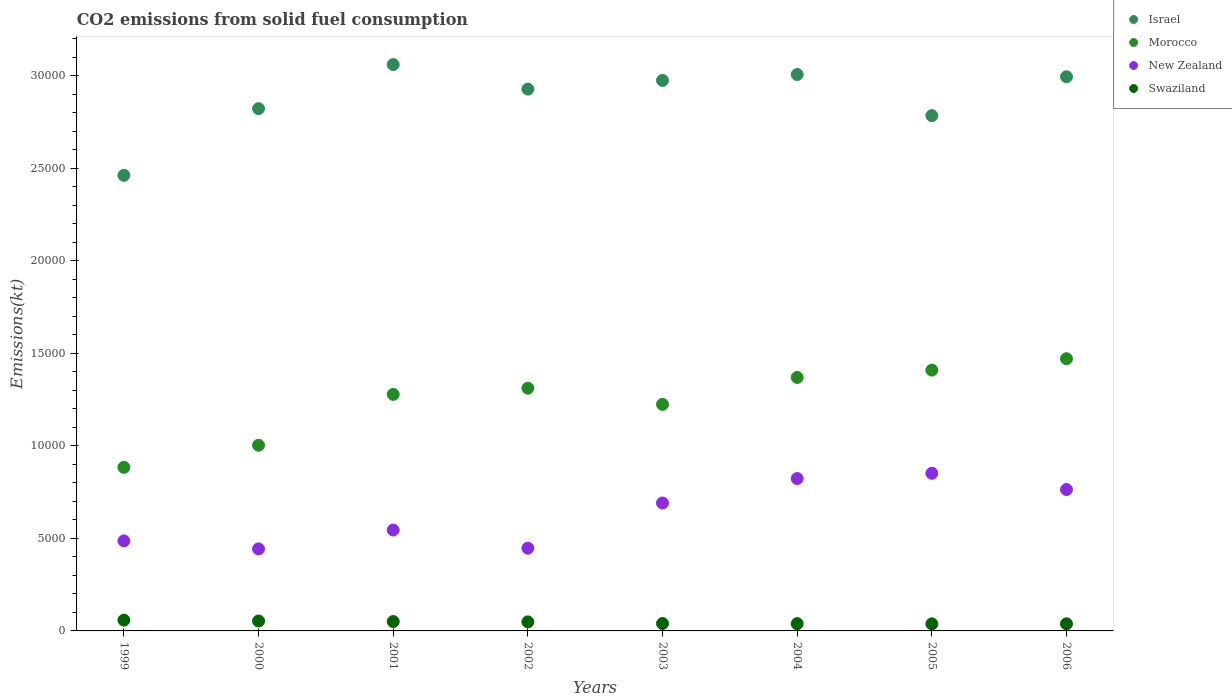How many different coloured dotlines are there?
Provide a short and direct response. 4. What is the amount of CO2 emitted in Israel in 2004?
Your response must be concise. 3.01e+04. Across all years, what is the maximum amount of CO2 emitted in Israel?
Provide a short and direct response. 3.06e+04. Across all years, what is the minimum amount of CO2 emitted in Israel?
Provide a succinct answer. 2.46e+04. In which year was the amount of CO2 emitted in New Zealand maximum?
Offer a very short reply. 2005. In which year was the amount of CO2 emitted in New Zealand minimum?
Your answer should be very brief. 2000. What is the total amount of CO2 emitted in Morocco in the graph?
Keep it short and to the point. 9.95e+04. What is the difference between the amount of CO2 emitted in New Zealand in 2003 and that in 2005?
Offer a terse response. -1606.15. What is the difference between the amount of CO2 emitted in Israel in 2006 and the amount of CO2 emitted in Morocco in 2002?
Provide a short and direct response. 1.68e+04. What is the average amount of CO2 emitted in Israel per year?
Your answer should be compact. 2.88e+04. In the year 2001, what is the difference between the amount of CO2 emitted in New Zealand and amount of CO2 emitted in Israel?
Give a very brief answer. -2.52e+04. What is the ratio of the amount of CO2 emitted in Swaziland in 2002 to that in 2006?
Your answer should be compact. 1.27. What is the difference between the highest and the second highest amount of CO2 emitted in Israel?
Your response must be concise. 539.05. What is the difference between the highest and the lowest amount of CO2 emitted in Israel?
Ensure brevity in your answer.  5988.21. In how many years, is the amount of CO2 emitted in Morocco greater than the average amount of CO2 emitted in Morocco taken over all years?
Your answer should be compact. 5. Is it the case that in every year, the sum of the amount of CO2 emitted in New Zealand and amount of CO2 emitted in Swaziland  is greater than the amount of CO2 emitted in Israel?
Provide a succinct answer. No. Does the amount of CO2 emitted in Israel monotonically increase over the years?
Your response must be concise. No. Is the amount of CO2 emitted in New Zealand strictly greater than the amount of CO2 emitted in Israel over the years?
Make the answer very short. No. Is the amount of CO2 emitted in Swaziland strictly less than the amount of CO2 emitted in New Zealand over the years?
Your response must be concise. Yes. Are the values on the major ticks of Y-axis written in scientific E-notation?
Keep it short and to the point. No. Does the graph contain grids?
Ensure brevity in your answer.  No. How many legend labels are there?
Make the answer very short. 4. How are the legend labels stacked?
Ensure brevity in your answer.  Vertical. What is the title of the graph?
Provide a short and direct response. CO2 emissions from solid fuel consumption. Does "Senegal" appear as one of the legend labels in the graph?
Your answer should be compact. No. What is the label or title of the Y-axis?
Keep it short and to the point. Emissions(kt). What is the Emissions(kt) of Israel in 1999?
Provide a succinct answer. 2.46e+04. What is the Emissions(kt) of Morocco in 1999?
Ensure brevity in your answer.  8841.14. What is the Emissions(kt) of New Zealand in 1999?
Your answer should be compact. 4866.11. What is the Emissions(kt) in Swaziland in 1999?
Your answer should be compact. 583.05. What is the Emissions(kt) of Israel in 2000?
Keep it short and to the point. 2.82e+04. What is the Emissions(kt) of Morocco in 2000?
Your answer should be compact. 1.00e+04. What is the Emissions(kt) of New Zealand in 2000?
Your answer should be compact. 4433.4. What is the Emissions(kt) in Swaziland in 2000?
Your answer should be very brief. 535.38. What is the Emissions(kt) in Israel in 2001?
Provide a succinct answer. 3.06e+04. What is the Emissions(kt) of Morocco in 2001?
Offer a very short reply. 1.28e+04. What is the Emissions(kt) of New Zealand in 2001?
Keep it short and to the point. 5452.83. What is the Emissions(kt) of Swaziland in 2001?
Provide a short and direct response. 506.05. What is the Emissions(kt) of Israel in 2002?
Your answer should be very brief. 2.93e+04. What is the Emissions(kt) of Morocco in 2002?
Make the answer very short. 1.31e+04. What is the Emissions(kt) in New Zealand in 2002?
Provide a short and direct response. 4470.07. What is the Emissions(kt) of Swaziland in 2002?
Your answer should be very brief. 487.71. What is the Emissions(kt) of Israel in 2003?
Offer a terse response. 2.98e+04. What is the Emissions(kt) of Morocco in 2003?
Provide a succinct answer. 1.22e+04. What is the Emissions(kt) of New Zealand in 2003?
Keep it short and to the point. 6912.3. What is the Emissions(kt) in Swaziland in 2003?
Offer a very short reply. 399.7. What is the Emissions(kt) of Israel in 2004?
Your answer should be compact. 3.01e+04. What is the Emissions(kt) in Morocco in 2004?
Offer a very short reply. 1.37e+04. What is the Emissions(kt) of New Zealand in 2004?
Ensure brevity in your answer.  8236.08. What is the Emissions(kt) in Swaziland in 2004?
Give a very brief answer. 392.37. What is the Emissions(kt) in Israel in 2005?
Ensure brevity in your answer.  2.79e+04. What is the Emissions(kt) in Morocco in 2005?
Provide a succinct answer. 1.41e+04. What is the Emissions(kt) in New Zealand in 2005?
Offer a very short reply. 8518.44. What is the Emissions(kt) of Swaziland in 2005?
Ensure brevity in your answer.  381.37. What is the Emissions(kt) of Israel in 2006?
Offer a terse response. 3.00e+04. What is the Emissions(kt) of Morocco in 2006?
Provide a short and direct response. 1.47e+04. What is the Emissions(kt) in New Zealand in 2006?
Offer a very short reply. 7642.03. What is the Emissions(kt) of Swaziland in 2006?
Provide a succinct answer. 385.04. Across all years, what is the maximum Emissions(kt) in Israel?
Offer a terse response. 3.06e+04. Across all years, what is the maximum Emissions(kt) in Morocco?
Give a very brief answer. 1.47e+04. Across all years, what is the maximum Emissions(kt) of New Zealand?
Ensure brevity in your answer.  8518.44. Across all years, what is the maximum Emissions(kt) in Swaziland?
Your answer should be compact. 583.05. Across all years, what is the minimum Emissions(kt) in Israel?
Make the answer very short. 2.46e+04. Across all years, what is the minimum Emissions(kt) in Morocco?
Provide a short and direct response. 8841.14. Across all years, what is the minimum Emissions(kt) of New Zealand?
Give a very brief answer. 4433.4. Across all years, what is the minimum Emissions(kt) of Swaziland?
Your answer should be very brief. 381.37. What is the total Emissions(kt) in Israel in the graph?
Ensure brevity in your answer.  2.30e+05. What is the total Emissions(kt) of Morocco in the graph?
Your response must be concise. 9.95e+04. What is the total Emissions(kt) of New Zealand in the graph?
Provide a succinct answer. 5.05e+04. What is the total Emissions(kt) of Swaziland in the graph?
Make the answer very short. 3670.67. What is the difference between the Emissions(kt) of Israel in 1999 and that in 2000?
Your answer should be very brief. -3604.66. What is the difference between the Emissions(kt) in Morocco in 1999 and that in 2000?
Provide a succinct answer. -1195.44. What is the difference between the Emissions(kt) of New Zealand in 1999 and that in 2000?
Make the answer very short. 432.71. What is the difference between the Emissions(kt) in Swaziland in 1999 and that in 2000?
Ensure brevity in your answer.  47.67. What is the difference between the Emissions(kt) in Israel in 1999 and that in 2001?
Ensure brevity in your answer.  -5988.21. What is the difference between the Emissions(kt) in Morocco in 1999 and that in 2001?
Provide a succinct answer. -3942.03. What is the difference between the Emissions(kt) in New Zealand in 1999 and that in 2001?
Offer a terse response. -586.72. What is the difference between the Emissions(kt) of Swaziland in 1999 and that in 2001?
Ensure brevity in your answer.  77.01. What is the difference between the Emissions(kt) of Israel in 1999 and that in 2002?
Offer a very short reply. -4660.76. What is the difference between the Emissions(kt) in Morocco in 1999 and that in 2002?
Provide a succinct answer. -4275.72. What is the difference between the Emissions(kt) of New Zealand in 1999 and that in 2002?
Offer a very short reply. 396.04. What is the difference between the Emissions(kt) in Swaziland in 1999 and that in 2002?
Offer a very short reply. 95.34. What is the difference between the Emissions(kt) of Israel in 1999 and that in 2003?
Your answer should be compact. -5130.13. What is the difference between the Emissions(kt) in Morocco in 1999 and that in 2003?
Offer a terse response. -3402.98. What is the difference between the Emissions(kt) of New Zealand in 1999 and that in 2003?
Your response must be concise. -2046.19. What is the difference between the Emissions(kt) in Swaziland in 1999 and that in 2003?
Ensure brevity in your answer.  183.35. What is the difference between the Emissions(kt) in Israel in 1999 and that in 2004?
Your response must be concise. -5449.16. What is the difference between the Emissions(kt) in Morocco in 1999 and that in 2004?
Offer a terse response. -4858.77. What is the difference between the Emissions(kt) of New Zealand in 1999 and that in 2004?
Provide a succinct answer. -3369.97. What is the difference between the Emissions(kt) of Swaziland in 1999 and that in 2004?
Offer a very short reply. 190.68. What is the difference between the Emissions(kt) in Israel in 1999 and that in 2005?
Your response must be concise. -3226.96. What is the difference between the Emissions(kt) of Morocco in 1999 and that in 2005?
Offer a terse response. -5254.81. What is the difference between the Emissions(kt) in New Zealand in 1999 and that in 2005?
Your answer should be very brief. -3652.33. What is the difference between the Emissions(kt) in Swaziland in 1999 and that in 2005?
Make the answer very short. 201.69. What is the difference between the Emissions(kt) in Israel in 1999 and that in 2006?
Make the answer very short. -5328.15. What is the difference between the Emissions(kt) in Morocco in 1999 and that in 2006?
Keep it short and to the point. -5870.87. What is the difference between the Emissions(kt) in New Zealand in 1999 and that in 2006?
Your answer should be compact. -2775.92. What is the difference between the Emissions(kt) of Swaziland in 1999 and that in 2006?
Your answer should be compact. 198.02. What is the difference between the Emissions(kt) of Israel in 2000 and that in 2001?
Provide a short and direct response. -2383.55. What is the difference between the Emissions(kt) in Morocco in 2000 and that in 2001?
Your answer should be compact. -2746.58. What is the difference between the Emissions(kt) of New Zealand in 2000 and that in 2001?
Make the answer very short. -1019.43. What is the difference between the Emissions(kt) of Swaziland in 2000 and that in 2001?
Keep it short and to the point. 29.34. What is the difference between the Emissions(kt) of Israel in 2000 and that in 2002?
Provide a short and direct response. -1056.1. What is the difference between the Emissions(kt) of Morocco in 2000 and that in 2002?
Make the answer very short. -3080.28. What is the difference between the Emissions(kt) in New Zealand in 2000 and that in 2002?
Give a very brief answer. -36.67. What is the difference between the Emissions(kt) in Swaziland in 2000 and that in 2002?
Ensure brevity in your answer.  47.67. What is the difference between the Emissions(kt) of Israel in 2000 and that in 2003?
Ensure brevity in your answer.  -1525.47. What is the difference between the Emissions(kt) of Morocco in 2000 and that in 2003?
Offer a terse response. -2207.53. What is the difference between the Emissions(kt) in New Zealand in 2000 and that in 2003?
Offer a very short reply. -2478.89. What is the difference between the Emissions(kt) in Swaziland in 2000 and that in 2003?
Offer a very short reply. 135.68. What is the difference between the Emissions(kt) in Israel in 2000 and that in 2004?
Provide a succinct answer. -1844.5. What is the difference between the Emissions(kt) in Morocco in 2000 and that in 2004?
Ensure brevity in your answer.  -3663.33. What is the difference between the Emissions(kt) of New Zealand in 2000 and that in 2004?
Offer a very short reply. -3802.68. What is the difference between the Emissions(kt) in Swaziland in 2000 and that in 2004?
Provide a short and direct response. 143.01. What is the difference between the Emissions(kt) in Israel in 2000 and that in 2005?
Your response must be concise. 377.7. What is the difference between the Emissions(kt) of Morocco in 2000 and that in 2005?
Your answer should be very brief. -4059.37. What is the difference between the Emissions(kt) in New Zealand in 2000 and that in 2005?
Offer a very short reply. -4085.04. What is the difference between the Emissions(kt) of Swaziland in 2000 and that in 2005?
Your answer should be very brief. 154.01. What is the difference between the Emissions(kt) of Israel in 2000 and that in 2006?
Provide a short and direct response. -1723.49. What is the difference between the Emissions(kt) in Morocco in 2000 and that in 2006?
Ensure brevity in your answer.  -4675.43. What is the difference between the Emissions(kt) in New Zealand in 2000 and that in 2006?
Give a very brief answer. -3208.62. What is the difference between the Emissions(kt) of Swaziland in 2000 and that in 2006?
Your response must be concise. 150.35. What is the difference between the Emissions(kt) in Israel in 2001 and that in 2002?
Your answer should be compact. 1327.45. What is the difference between the Emissions(kt) in Morocco in 2001 and that in 2002?
Give a very brief answer. -333.7. What is the difference between the Emissions(kt) of New Zealand in 2001 and that in 2002?
Your answer should be compact. 982.76. What is the difference between the Emissions(kt) in Swaziland in 2001 and that in 2002?
Your response must be concise. 18.34. What is the difference between the Emissions(kt) of Israel in 2001 and that in 2003?
Make the answer very short. 858.08. What is the difference between the Emissions(kt) of Morocco in 2001 and that in 2003?
Your response must be concise. 539.05. What is the difference between the Emissions(kt) of New Zealand in 2001 and that in 2003?
Offer a terse response. -1459.47. What is the difference between the Emissions(kt) in Swaziland in 2001 and that in 2003?
Provide a short and direct response. 106.34. What is the difference between the Emissions(kt) of Israel in 2001 and that in 2004?
Make the answer very short. 539.05. What is the difference between the Emissions(kt) in Morocco in 2001 and that in 2004?
Provide a short and direct response. -916.75. What is the difference between the Emissions(kt) of New Zealand in 2001 and that in 2004?
Provide a short and direct response. -2783.25. What is the difference between the Emissions(kt) in Swaziland in 2001 and that in 2004?
Ensure brevity in your answer.  113.68. What is the difference between the Emissions(kt) in Israel in 2001 and that in 2005?
Offer a very short reply. 2761.25. What is the difference between the Emissions(kt) of Morocco in 2001 and that in 2005?
Make the answer very short. -1312.79. What is the difference between the Emissions(kt) of New Zealand in 2001 and that in 2005?
Your response must be concise. -3065.61. What is the difference between the Emissions(kt) in Swaziland in 2001 and that in 2005?
Your answer should be compact. 124.68. What is the difference between the Emissions(kt) of Israel in 2001 and that in 2006?
Offer a very short reply. 660.06. What is the difference between the Emissions(kt) of Morocco in 2001 and that in 2006?
Make the answer very short. -1928.84. What is the difference between the Emissions(kt) in New Zealand in 2001 and that in 2006?
Your answer should be compact. -2189.2. What is the difference between the Emissions(kt) in Swaziland in 2001 and that in 2006?
Your response must be concise. 121.01. What is the difference between the Emissions(kt) in Israel in 2002 and that in 2003?
Your response must be concise. -469.38. What is the difference between the Emissions(kt) of Morocco in 2002 and that in 2003?
Your answer should be compact. 872.75. What is the difference between the Emissions(kt) of New Zealand in 2002 and that in 2003?
Offer a terse response. -2442.22. What is the difference between the Emissions(kt) of Swaziland in 2002 and that in 2003?
Keep it short and to the point. 88.01. What is the difference between the Emissions(kt) of Israel in 2002 and that in 2004?
Your answer should be compact. -788.4. What is the difference between the Emissions(kt) of Morocco in 2002 and that in 2004?
Ensure brevity in your answer.  -583.05. What is the difference between the Emissions(kt) in New Zealand in 2002 and that in 2004?
Keep it short and to the point. -3766.01. What is the difference between the Emissions(kt) in Swaziland in 2002 and that in 2004?
Keep it short and to the point. 95.34. What is the difference between the Emissions(kt) in Israel in 2002 and that in 2005?
Ensure brevity in your answer.  1433.8. What is the difference between the Emissions(kt) of Morocco in 2002 and that in 2005?
Your answer should be very brief. -979.09. What is the difference between the Emissions(kt) of New Zealand in 2002 and that in 2005?
Provide a succinct answer. -4048.37. What is the difference between the Emissions(kt) of Swaziland in 2002 and that in 2005?
Offer a terse response. 106.34. What is the difference between the Emissions(kt) of Israel in 2002 and that in 2006?
Your answer should be compact. -667.39. What is the difference between the Emissions(kt) in Morocco in 2002 and that in 2006?
Your answer should be very brief. -1595.14. What is the difference between the Emissions(kt) in New Zealand in 2002 and that in 2006?
Keep it short and to the point. -3171.95. What is the difference between the Emissions(kt) of Swaziland in 2002 and that in 2006?
Give a very brief answer. 102.68. What is the difference between the Emissions(kt) of Israel in 2003 and that in 2004?
Offer a terse response. -319.03. What is the difference between the Emissions(kt) of Morocco in 2003 and that in 2004?
Provide a short and direct response. -1455.8. What is the difference between the Emissions(kt) of New Zealand in 2003 and that in 2004?
Your response must be concise. -1323.79. What is the difference between the Emissions(kt) in Swaziland in 2003 and that in 2004?
Offer a very short reply. 7.33. What is the difference between the Emissions(kt) of Israel in 2003 and that in 2005?
Your answer should be very brief. 1903.17. What is the difference between the Emissions(kt) of Morocco in 2003 and that in 2005?
Your answer should be very brief. -1851.84. What is the difference between the Emissions(kt) in New Zealand in 2003 and that in 2005?
Provide a succinct answer. -1606.15. What is the difference between the Emissions(kt) in Swaziland in 2003 and that in 2005?
Give a very brief answer. 18.34. What is the difference between the Emissions(kt) in Israel in 2003 and that in 2006?
Your answer should be very brief. -198.02. What is the difference between the Emissions(kt) of Morocco in 2003 and that in 2006?
Your answer should be very brief. -2467.89. What is the difference between the Emissions(kt) of New Zealand in 2003 and that in 2006?
Give a very brief answer. -729.73. What is the difference between the Emissions(kt) of Swaziland in 2003 and that in 2006?
Your response must be concise. 14.67. What is the difference between the Emissions(kt) of Israel in 2004 and that in 2005?
Your answer should be compact. 2222.2. What is the difference between the Emissions(kt) of Morocco in 2004 and that in 2005?
Give a very brief answer. -396.04. What is the difference between the Emissions(kt) of New Zealand in 2004 and that in 2005?
Give a very brief answer. -282.36. What is the difference between the Emissions(kt) of Swaziland in 2004 and that in 2005?
Offer a very short reply. 11. What is the difference between the Emissions(kt) in Israel in 2004 and that in 2006?
Offer a very short reply. 121.01. What is the difference between the Emissions(kt) of Morocco in 2004 and that in 2006?
Offer a very short reply. -1012.09. What is the difference between the Emissions(kt) in New Zealand in 2004 and that in 2006?
Offer a very short reply. 594.05. What is the difference between the Emissions(kt) of Swaziland in 2004 and that in 2006?
Your response must be concise. 7.33. What is the difference between the Emissions(kt) in Israel in 2005 and that in 2006?
Keep it short and to the point. -2101.19. What is the difference between the Emissions(kt) in Morocco in 2005 and that in 2006?
Provide a short and direct response. -616.06. What is the difference between the Emissions(kt) in New Zealand in 2005 and that in 2006?
Your response must be concise. 876.41. What is the difference between the Emissions(kt) of Swaziland in 2005 and that in 2006?
Offer a very short reply. -3.67. What is the difference between the Emissions(kt) of Israel in 1999 and the Emissions(kt) of Morocco in 2000?
Offer a terse response. 1.46e+04. What is the difference between the Emissions(kt) in Israel in 1999 and the Emissions(kt) in New Zealand in 2000?
Offer a very short reply. 2.02e+04. What is the difference between the Emissions(kt) in Israel in 1999 and the Emissions(kt) in Swaziland in 2000?
Your answer should be compact. 2.41e+04. What is the difference between the Emissions(kt) in Morocco in 1999 and the Emissions(kt) in New Zealand in 2000?
Offer a terse response. 4407.73. What is the difference between the Emissions(kt) in Morocco in 1999 and the Emissions(kt) in Swaziland in 2000?
Offer a very short reply. 8305.75. What is the difference between the Emissions(kt) in New Zealand in 1999 and the Emissions(kt) in Swaziland in 2000?
Make the answer very short. 4330.73. What is the difference between the Emissions(kt) of Israel in 1999 and the Emissions(kt) of Morocco in 2001?
Provide a short and direct response. 1.18e+04. What is the difference between the Emissions(kt) of Israel in 1999 and the Emissions(kt) of New Zealand in 2001?
Your answer should be compact. 1.92e+04. What is the difference between the Emissions(kt) of Israel in 1999 and the Emissions(kt) of Swaziland in 2001?
Your answer should be compact. 2.41e+04. What is the difference between the Emissions(kt) in Morocco in 1999 and the Emissions(kt) in New Zealand in 2001?
Give a very brief answer. 3388.31. What is the difference between the Emissions(kt) in Morocco in 1999 and the Emissions(kt) in Swaziland in 2001?
Provide a short and direct response. 8335.09. What is the difference between the Emissions(kt) in New Zealand in 1999 and the Emissions(kt) in Swaziland in 2001?
Your answer should be compact. 4360.06. What is the difference between the Emissions(kt) of Israel in 1999 and the Emissions(kt) of Morocco in 2002?
Your answer should be very brief. 1.15e+04. What is the difference between the Emissions(kt) of Israel in 1999 and the Emissions(kt) of New Zealand in 2002?
Ensure brevity in your answer.  2.02e+04. What is the difference between the Emissions(kt) in Israel in 1999 and the Emissions(kt) in Swaziland in 2002?
Your response must be concise. 2.41e+04. What is the difference between the Emissions(kt) of Morocco in 1999 and the Emissions(kt) of New Zealand in 2002?
Your response must be concise. 4371.06. What is the difference between the Emissions(kt) in Morocco in 1999 and the Emissions(kt) in Swaziland in 2002?
Provide a succinct answer. 8353.43. What is the difference between the Emissions(kt) in New Zealand in 1999 and the Emissions(kt) in Swaziland in 2002?
Give a very brief answer. 4378.4. What is the difference between the Emissions(kt) of Israel in 1999 and the Emissions(kt) of Morocco in 2003?
Provide a succinct answer. 1.24e+04. What is the difference between the Emissions(kt) of Israel in 1999 and the Emissions(kt) of New Zealand in 2003?
Your response must be concise. 1.77e+04. What is the difference between the Emissions(kt) of Israel in 1999 and the Emissions(kt) of Swaziland in 2003?
Your answer should be very brief. 2.42e+04. What is the difference between the Emissions(kt) of Morocco in 1999 and the Emissions(kt) of New Zealand in 2003?
Make the answer very short. 1928.84. What is the difference between the Emissions(kt) in Morocco in 1999 and the Emissions(kt) in Swaziland in 2003?
Your response must be concise. 8441.43. What is the difference between the Emissions(kt) of New Zealand in 1999 and the Emissions(kt) of Swaziland in 2003?
Your answer should be very brief. 4466.41. What is the difference between the Emissions(kt) of Israel in 1999 and the Emissions(kt) of Morocco in 2004?
Keep it short and to the point. 1.09e+04. What is the difference between the Emissions(kt) in Israel in 1999 and the Emissions(kt) in New Zealand in 2004?
Provide a short and direct response. 1.64e+04. What is the difference between the Emissions(kt) in Israel in 1999 and the Emissions(kt) in Swaziland in 2004?
Your response must be concise. 2.42e+04. What is the difference between the Emissions(kt) in Morocco in 1999 and the Emissions(kt) in New Zealand in 2004?
Offer a terse response. 605.05. What is the difference between the Emissions(kt) in Morocco in 1999 and the Emissions(kt) in Swaziland in 2004?
Keep it short and to the point. 8448.77. What is the difference between the Emissions(kt) of New Zealand in 1999 and the Emissions(kt) of Swaziland in 2004?
Your answer should be very brief. 4473.74. What is the difference between the Emissions(kt) in Israel in 1999 and the Emissions(kt) in Morocco in 2005?
Give a very brief answer. 1.05e+04. What is the difference between the Emissions(kt) of Israel in 1999 and the Emissions(kt) of New Zealand in 2005?
Your response must be concise. 1.61e+04. What is the difference between the Emissions(kt) of Israel in 1999 and the Emissions(kt) of Swaziland in 2005?
Offer a terse response. 2.42e+04. What is the difference between the Emissions(kt) in Morocco in 1999 and the Emissions(kt) in New Zealand in 2005?
Keep it short and to the point. 322.7. What is the difference between the Emissions(kt) of Morocco in 1999 and the Emissions(kt) of Swaziland in 2005?
Your answer should be compact. 8459.77. What is the difference between the Emissions(kt) of New Zealand in 1999 and the Emissions(kt) of Swaziland in 2005?
Ensure brevity in your answer.  4484.74. What is the difference between the Emissions(kt) of Israel in 1999 and the Emissions(kt) of Morocco in 2006?
Provide a short and direct response. 9911.9. What is the difference between the Emissions(kt) of Israel in 1999 and the Emissions(kt) of New Zealand in 2006?
Offer a terse response. 1.70e+04. What is the difference between the Emissions(kt) of Israel in 1999 and the Emissions(kt) of Swaziland in 2006?
Make the answer very short. 2.42e+04. What is the difference between the Emissions(kt) of Morocco in 1999 and the Emissions(kt) of New Zealand in 2006?
Offer a terse response. 1199.11. What is the difference between the Emissions(kt) in Morocco in 1999 and the Emissions(kt) in Swaziland in 2006?
Give a very brief answer. 8456.1. What is the difference between the Emissions(kt) of New Zealand in 1999 and the Emissions(kt) of Swaziland in 2006?
Your response must be concise. 4481.07. What is the difference between the Emissions(kt) of Israel in 2000 and the Emissions(kt) of Morocco in 2001?
Your answer should be compact. 1.54e+04. What is the difference between the Emissions(kt) in Israel in 2000 and the Emissions(kt) in New Zealand in 2001?
Offer a terse response. 2.28e+04. What is the difference between the Emissions(kt) of Israel in 2000 and the Emissions(kt) of Swaziland in 2001?
Make the answer very short. 2.77e+04. What is the difference between the Emissions(kt) in Morocco in 2000 and the Emissions(kt) in New Zealand in 2001?
Keep it short and to the point. 4583.75. What is the difference between the Emissions(kt) in Morocco in 2000 and the Emissions(kt) in Swaziland in 2001?
Your answer should be very brief. 9530.53. What is the difference between the Emissions(kt) of New Zealand in 2000 and the Emissions(kt) of Swaziland in 2001?
Give a very brief answer. 3927.36. What is the difference between the Emissions(kt) in Israel in 2000 and the Emissions(kt) in Morocco in 2002?
Offer a terse response. 1.51e+04. What is the difference between the Emissions(kt) of Israel in 2000 and the Emissions(kt) of New Zealand in 2002?
Give a very brief answer. 2.38e+04. What is the difference between the Emissions(kt) in Israel in 2000 and the Emissions(kt) in Swaziland in 2002?
Offer a terse response. 2.77e+04. What is the difference between the Emissions(kt) of Morocco in 2000 and the Emissions(kt) of New Zealand in 2002?
Keep it short and to the point. 5566.51. What is the difference between the Emissions(kt) in Morocco in 2000 and the Emissions(kt) in Swaziland in 2002?
Keep it short and to the point. 9548.87. What is the difference between the Emissions(kt) of New Zealand in 2000 and the Emissions(kt) of Swaziland in 2002?
Your answer should be compact. 3945.69. What is the difference between the Emissions(kt) of Israel in 2000 and the Emissions(kt) of Morocco in 2003?
Offer a very short reply. 1.60e+04. What is the difference between the Emissions(kt) of Israel in 2000 and the Emissions(kt) of New Zealand in 2003?
Provide a short and direct response. 2.13e+04. What is the difference between the Emissions(kt) of Israel in 2000 and the Emissions(kt) of Swaziland in 2003?
Offer a very short reply. 2.78e+04. What is the difference between the Emissions(kt) in Morocco in 2000 and the Emissions(kt) in New Zealand in 2003?
Your answer should be very brief. 3124.28. What is the difference between the Emissions(kt) in Morocco in 2000 and the Emissions(kt) in Swaziland in 2003?
Your answer should be very brief. 9636.88. What is the difference between the Emissions(kt) in New Zealand in 2000 and the Emissions(kt) in Swaziland in 2003?
Keep it short and to the point. 4033.7. What is the difference between the Emissions(kt) of Israel in 2000 and the Emissions(kt) of Morocco in 2004?
Provide a short and direct response. 1.45e+04. What is the difference between the Emissions(kt) of Israel in 2000 and the Emissions(kt) of New Zealand in 2004?
Provide a short and direct response. 2.00e+04. What is the difference between the Emissions(kt) in Israel in 2000 and the Emissions(kt) in Swaziland in 2004?
Offer a very short reply. 2.78e+04. What is the difference between the Emissions(kt) of Morocco in 2000 and the Emissions(kt) of New Zealand in 2004?
Your response must be concise. 1800.5. What is the difference between the Emissions(kt) in Morocco in 2000 and the Emissions(kt) in Swaziland in 2004?
Provide a short and direct response. 9644.21. What is the difference between the Emissions(kt) of New Zealand in 2000 and the Emissions(kt) of Swaziland in 2004?
Keep it short and to the point. 4041.03. What is the difference between the Emissions(kt) in Israel in 2000 and the Emissions(kt) in Morocco in 2005?
Your answer should be compact. 1.41e+04. What is the difference between the Emissions(kt) of Israel in 2000 and the Emissions(kt) of New Zealand in 2005?
Your answer should be very brief. 1.97e+04. What is the difference between the Emissions(kt) in Israel in 2000 and the Emissions(kt) in Swaziland in 2005?
Keep it short and to the point. 2.78e+04. What is the difference between the Emissions(kt) in Morocco in 2000 and the Emissions(kt) in New Zealand in 2005?
Offer a very short reply. 1518.14. What is the difference between the Emissions(kt) of Morocco in 2000 and the Emissions(kt) of Swaziland in 2005?
Offer a very short reply. 9655.21. What is the difference between the Emissions(kt) of New Zealand in 2000 and the Emissions(kt) of Swaziland in 2005?
Ensure brevity in your answer.  4052.03. What is the difference between the Emissions(kt) of Israel in 2000 and the Emissions(kt) of Morocco in 2006?
Your answer should be very brief. 1.35e+04. What is the difference between the Emissions(kt) in Israel in 2000 and the Emissions(kt) in New Zealand in 2006?
Give a very brief answer. 2.06e+04. What is the difference between the Emissions(kt) of Israel in 2000 and the Emissions(kt) of Swaziland in 2006?
Offer a very short reply. 2.78e+04. What is the difference between the Emissions(kt) in Morocco in 2000 and the Emissions(kt) in New Zealand in 2006?
Your response must be concise. 2394.55. What is the difference between the Emissions(kt) of Morocco in 2000 and the Emissions(kt) of Swaziland in 2006?
Your answer should be very brief. 9651.54. What is the difference between the Emissions(kt) of New Zealand in 2000 and the Emissions(kt) of Swaziland in 2006?
Your response must be concise. 4048.37. What is the difference between the Emissions(kt) in Israel in 2001 and the Emissions(kt) in Morocco in 2002?
Give a very brief answer. 1.75e+04. What is the difference between the Emissions(kt) of Israel in 2001 and the Emissions(kt) of New Zealand in 2002?
Provide a succinct answer. 2.61e+04. What is the difference between the Emissions(kt) of Israel in 2001 and the Emissions(kt) of Swaziland in 2002?
Your response must be concise. 3.01e+04. What is the difference between the Emissions(kt) of Morocco in 2001 and the Emissions(kt) of New Zealand in 2002?
Your response must be concise. 8313.09. What is the difference between the Emissions(kt) of Morocco in 2001 and the Emissions(kt) of Swaziland in 2002?
Your answer should be very brief. 1.23e+04. What is the difference between the Emissions(kt) of New Zealand in 2001 and the Emissions(kt) of Swaziland in 2002?
Your response must be concise. 4965.12. What is the difference between the Emissions(kt) of Israel in 2001 and the Emissions(kt) of Morocco in 2003?
Your answer should be very brief. 1.84e+04. What is the difference between the Emissions(kt) in Israel in 2001 and the Emissions(kt) in New Zealand in 2003?
Provide a succinct answer. 2.37e+04. What is the difference between the Emissions(kt) of Israel in 2001 and the Emissions(kt) of Swaziland in 2003?
Make the answer very short. 3.02e+04. What is the difference between the Emissions(kt) of Morocco in 2001 and the Emissions(kt) of New Zealand in 2003?
Your answer should be compact. 5870.87. What is the difference between the Emissions(kt) in Morocco in 2001 and the Emissions(kt) in Swaziland in 2003?
Offer a very short reply. 1.24e+04. What is the difference between the Emissions(kt) in New Zealand in 2001 and the Emissions(kt) in Swaziland in 2003?
Provide a short and direct response. 5053.13. What is the difference between the Emissions(kt) in Israel in 2001 and the Emissions(kt) in Morocco in 2004?
Ensure brevity in your answer.  1.69e+04. What is the difference between the Emissions(kt) in Israel in 2001 and the Emissions(kt) in New Zealand in 2004?
Provide a short and direct response. 2.24e+04. What is the difference between the Emissions(kt) of Israel in 2001 and the Emissions(kt) of Swaziland in 2004?
Provide a short and direct response. 3.02e+04. What is the difference between the Emissions(kt) in Morocco in 2001 and the Emissions(kt) in New Zealand in 2004?
Offer a terse response. 4547.08. What is the difference between the Emissions(kt) in Morocco in 2001 and the Emissions(kt) in Swaziland in 2004?
Give a very brief answer. 1.24e+04. What is the difference between the Emissions(kt) in New Zealand in 2001 and the Emissions(kt) in Swaziland in 2004?
Your answer should be very brief. 5060.46. What is the difference between the Emissions(kt) of Israel in 2001 and the Emissions(kt) of Morocco in 2005?
Your answer should be compact. 1.65e+04. What is the difference between the Emissions(kt) in Israel in 2001 and the Emissions(kt) in New Zealand in 2005?
Your answer should be compact. 2.21e+04. What is the difference between the Emissions(kt) in Israel in 2001 and the Emissions(kt) in Swaziland in 2005?
Your response must be concise. 3.02e+04. What is the difference between the Emissions(kt) of Morocco in 2001 and the Emissions(kt) of New Zealand in 2005?
Ensure brevity in your answer.  4264.72. What is the difference between the Emissions(kt) of Morocco in 2001 and the Emissions(kt) of Swaziland in 2005?
Provide a short and direct response. 1.24e+04. What is the difference between the Emissions(kt) in New Zealand in 2001 and the Emissions(kt) in Swaziland in 2005?
Make the answer very short. 5071.46. What is the difference between the Emissions(kt) of Israel in 2001 and the Emissions(kt) of Morocco in 2006?
Offer a terse response. 1.59e+04. What is the difference between the Emissions(kt) of Israel in 2001 and the Emissions(kt) of New Zealand in 2006?
Your answer should be very brief. 2.30e+04. What is the difference between the Emissions(kt) of Israel in 2001 and the Emissions(kt) of Swaziland in 2006?
Make the answer very short. 3.02e+04. What is the difference between the Emissions(kt) in Morocco in 2001 and the Emissions(kt) in New Zealand in 2006?
Your answer should be compact. 5141.13. What is the difference between the Emissions(kt) in Morocco in 2001 and the Emissions(kt) in Swaziland in 2006?
Make the answer very short. 1.24e+04. What is the difference between the Emissions(kt) of New Zealand in 2001 and the Emissions(kt) of Swaziland in 2006?
Make the answer very short. 5067.79. What is the difference between the Emissions(kt) in Israel in 2002 and the Emissions(kt) in Morocco in 2003?
Give a very brief answer. 1.70e+04. What is the difference between the Emissions(kt) in Israel in 2002 and the Emissions(kt) in New Zealand in 2003?
Provide a short and direct response. 2.24e+04. What is the difference between the Emissions(kt) of Israel in 2002 and the Emissions(kt) of Swaziland in 2003?
Provide a short and direct response. 2.89e+04. What is the difference between the Emissions(kt) of Morocco in 2002 and the Emissions(kt) of New Zealand in 2003?
Ensure brevity in your answer.  6204.56. What is the difference between the Emissions(kt) in Morocco in 2002 and the Emissions(kt) in Swaziland in 2003?
Ensure brevity in your answer.  1.27e+04. What is the difference between the Emissions(kt) in New Zealand in 2002 and the Emissions(kt) in Swaziland in 2003?
Keep it short and to the point. 4070.37. What is the difference between the Emissions(kt) in Israel in 2002 and the Emissions(kt) in Morocco in 2004?
Offer a terse response. 1.56e+04. What is the difference between the Emissions(kt) in Israel in 2002 and the Emissions(kt) in New Zealand in 2004?
Provide a succinct answer. 2.10e+04. What is the difference between the Emissions(kt) in Israel in 2002 and the Emissions(kt) in Swaziland in 2004?
Your response must be concise. 2.89e+04. What is the difference between the Emissions(kt) of Morocco in 2002 and the Emissions(kt) of New Zealand in 2004?
Ensure brevity in your answer.  4880.78. What is the difference between the Emissions(kt) in Morocco in 2002 and the Emissions(kt) in Swaziland in 2004?
Offer a terse response. 1.27e+04. What is the difference between the Emissions(kt) in New Zealand in 2002 and the Emissions(kt) in Swaziland in 2004?
Keep it short and to the point. 4077.7. What is the difference between the Emissions(kt) of Israel in 2002 and the Emissions(kt) of Morocco in 2005?
Make the answer very short. 1.52e+04. What is the difference between the Emissions(kt) of Israel in 2002 and the Emissions(kt) of New Zealand in 2005?
Offer a terse response. 2.08e+04. What is the difference between the Emissions(kt) in Israel in 2002 and the Emissions(kt) in Swaziland in 2005?
Give a very brief answer. 2.89e+04. What is the difference between the Emissions(kt) of Morocco in 2002 and the Emissions(kt) of New Zealand in 2005?
Your answer should be very brief. 4598.42. What is the difference between the Emissions(kt) in Morocco in 2002 and the Emissions(kt) in Swaziland in 2005?
Your answer should be very brief. 1.27e+04. What is the difference between the Emissions(kt) of New Zealand in 2002 and the Emissions(kt) of Swaziland in 2005?
Your response must be concise. 4088.7. What is the difference between the Emissions(kt) in Israel in 2002 and the Emissions(kt) in Morocco in 2006?
Ensure brevity in your answer.  1.46e+04. What is the difference between the Emissions(kt) of Israel in 2002 and the Emissions(kt) of New Zealand in 2006?
Offer a very short reply. 2.16e+04. What is the difference between the Emissions(kt) in Israel in 2002 and the Emissions(kt) in Swaziland in 2006?
Give a very brief answer. 2.89e+04. What is the difference between the Emissions(kt) of Morocco in 2002 and the Emissions(kt) of New Zealand in 2006?
Offer a terse response. 5474.83. What is the difference between the Emissions(kt) in Morocco in 2002 and the Emissions(kt) in Swaziland in 2006?
Offer a very short reply. 1.27e+04. What is the difference between the Emissions(kt) in New Zealand in 2002 and the Emissions(kt) in Swaziland in 2006?
Your answer should be very brief. 4085.04. What is the difference between the Emissions(kt) in Israel in 2003 and the Emissions(kt) in Morocco in 2004?
Offer a very short reply. 1.61e+04. What is the difference between the Emissions(kt) of Israel in 2003 and the Emissions(kt) of New Zealand in 2004?
Provide a succinct answer. 2.15e+04. What is the difference between the Emissions(kt) in Israel in 2003 and the Emissions(kt) in Swaziland in 2004?
Your answer should be very brief. 2.94e+04. What is the difference between the Emissions(kt) in Morocco in 2003 and the Emissions(kt) in New Zealand in 2004?
Provide a succinct answer. 4008.03. What is the difference between the Emissions(kt) in Morocco in 2003 and the Emissions(kt) in Swaziland in 2004?
Give a very brief answer. 1.19e+04. What is the difference between the Emissions(kt) of New Zealand in 2003 and the Emissions(kt) of Swaziland in 2004?
Offer a terse response. 6519.93. What is the difference between the Emissions(kt) of Israel in 2003 and the Emissions(kt) of Morocco in 2005?
Your response must be concise. 1.57e+04. What is the difference between the Emissions(kt) of Israel in 2003 and the Emissions(kt) of New Zealand in 2005?
Make the answer very short. 2.12e+04. What is the difference between the Emissions(kt) of Israel in 2003 and the Emissions(kt) of Swaziland in 2005?
Provide a short and direct response. 2.94e+04. What is the difference between the Emissions(kt) of Morocco in 2003 and the Emissions(kt) of New Zealand in 2005?
Your response must be concise. 3725.67. What is the difference between the Emissions(kt) of Morocco in 2003 and the Emissions(kt) of Swaziland in 2005?
Ensure brevity in your answer.  1.19e+04. What is the difference between the Emissions(kt) in New Zealand in 2003 and the Emissions(kt) in Swaziland in 2005?
Your answer should be very brief. 6530.93. What is the difference between the Emissions(kt) of Israel in 2003 and the Emissions(kt) of Morocco in 2006?
Ensure brevity in your answer.  1.50e+04. What is the difference between the Emissions(kt) of Israel in 2003 and the Emissions(kt) of New Zealand in 2006?
Your answer should be compact. 2.21e+04. What is the difference between the Emissions(kt) of Israel in 2003 and the Emissions(kt) of Swaziland in 2006?
Your answer should be compact. 2.94e+04. What is the difference between the Emissions(kt) of Morocco in 2003 and the Emissions(kt) of New Zealand in 2006?
Offer a terse response. 4602.09. What is the difference between the Emissions(kt) of Morocco in 2003 and the Emissions(kt) of Swaziland in 2006?
Keep it short and to the point. 1.19e+04. What is the difference between the Emissions(kt) of New Zealand in 2003 and the Emissions(kt) of Swaziland in 2006?
Your response must be concise. 6527.26. What is the difference between the Emissions(kt) in Israel in 2004 and the Emissions(kt) in Morocco in 2005?
Offer a terse response. 1.60e+04. What is the difference between the Emissions(kt) in Israel in 2004 and the Emissions(kt) in New Zealand in 2005?
Offer a very short reply. 2.16e+04. What is the difference between the Emissions(kt) of Israel in 2004 and the Emissions(kt) of Swaziland in 2005?
Your answer should be compact. 2.97e+04. What is the difference between the Emissions(kt) in Morocco in 2004 and the Emissions(kt) in New Zealand in 2005?
Offer a very short reply. 5181.47. What is the difference between the Emissions(kt) in Morocco in 2004 and the Emissions(kt) in Swaziland in 2005?
Your response must be concise. 1.33e+04. What is the difference between the Emissions(kt) of New Zealand in 2004 and the Emissions(kt) of Swaziland in 2005?
Give a very brief answer. 7854.71. What is the difference between the Emissions(kt) in Israel in 2004 and the Emissions(kt) in Morocco in 2006?
Offer a terse response. 1.54e+04. What is the difference between the Emissions(kt) in Israel in 2004 and the Emissions(kt) in New Zealand in 2006?
Offer a very short reply. 2.24e+04. What is the difference between the Emissions(kt) in Israel in 2004 and the Emissions(kt) in Swaziland in 2006?
Your response must be concise. 2.97e+04. What is the difference between the Emissions(kt) in Morocco in 2004 and the Emissions(kt) in New Zealand in 2006?
Offer a very short reply. 6057.88. What is the difference between the Emissions(kt) of Morocco in 2004 and the Emissions(kt) of Swaziland in 2006?
Provide a succinct answer. 1.33e+04. What is the difference between the Emissions(kt) of New Zealand in 2004 and the Emissions(kt) of Swaziland in 2006?
Offer a very short reply. 7851.05. What is the difference between the Emissions(kt) of Israel in 2005 and the Emissions(kt) of Morocco in 2006?
Keep it short and to the point. 1.31e+04. What is the difference between the Emissions(kt) of Israel in 2005 and the Emissions(kt) of New Zealand in 2006?
Offer a terse response. 2.02e+04. What is the difference between the Emissions(kt) in Israel in 2005 and the Emissions(kt) in Swaziland in 2006?
Provide a succinct answer. 2.75e+04. What is the difference between the Emissions(kt) of Morocco in 2005 and the Emissions(kt) of New Zealand in 2006?
Keep it short and to the point. 6453.92. What is the difference between the Emissions(kt) in Morocco in 2005 and the Emissions(kt) in Swaziland in 2006?
Keep it short and to the point. 1.37e+04. What is the difference between the Emissions(kt) in New Zealand in 2005 and the Emissions(kt) in Swaziland in 2006?
Offer a terse response. 8133.41. What is the average Emissions(kt) of Israel per year?
Offer a very short reply. 2.88e+04. What is the average Emissions(kt) of Morocco per year?
Your answer should be compact. 1.24e+04. What is the average Emissions(kt) in New Zealand per year?
Your answer should be compact. 6316.41. What is the average Emissions(kt) in Swaziland per year?
Ensure brevity in your answer.  458.83. In the year 1999, what is the difference between the Emissions(kt) of Israel and Emissions(kt) of Morocco?
Offer a very short reply. 1.58e+04. In the year 1999, what is the difference between the Emissions(kt) of Israel and Emissions(kt) of New Zealand?
Keep it short and to the point. 1.98e+04. In the year 1999, what is the difference between the Emissions(kt) in Israel and Emissions(kt) in Swaziland?
Offer a terse response. 2.40e+04. In the year 1999, what is the difference between the Emissions(kt) in Morocco and Emissions(kt) in New Zealand?
Offer a very short reply. 3975.03. In the year 1999, what is the difference between the Emissions(kt) in Morocco and Emissions(kt) in Swaziland?
Offer a terse response. 8258.08. In the year 1999, what is the difference between the Emissions(kt) in New Zealand and Emissions(kt) in Swaziland?
Make the answer very short. 4283.06. In the year 2000, what is the difference between the Emissions(kt) in Israel and Emissions(kt) in Morocco?
Your answer should be very brief. 1.82e+04. In the year 2000, what is the difference between the Emissions(kt) of Israel and Emissions(kt) of New Zealand?
Provide a succinct answer. 2.38e+04. In the year 2000, what is the difference between the Emissions(kt) of Israel and Emissions(kt) of Swaziland?
Your response must be concise. 2.77e+04. In the year 2000, what is the difference between the Emissions(kt) in Morocco and Emissions(kt) in New Zealand?
Offer a terse response. 5603.18. In the year 2000, what is the difference between the Emissions(kt) of Morocco and Emissions(kt) of Swaziland?
Offer a very short reply. 9501.2. In the year 2000, what is the difference between the Emissions(kt) in New Zealand and Emissions(kt) in Swaziland?
Ensure brevity in your answer.  3898.02. In the year 2001, what is the difference between the Emissions(kt) of Israel and Emissions(kt) of Morocco?
Your response must be concise. 1.78e+04. In the year 2001, what is the difference between the Emissions(kt) in Israel and Emissions(kt) in New Zealand?
Give a very brief answer. 2.52e+04. In the year 2001, what is the difference between the Emissions(kt) in Israel and Emissions(kt) in Swaziland?
Keep it short and to the point. 3.01e+04. In the year 2001, what is the difference between the Emissions(kt) in Morocco and Emissions(kt) in New Zealand?
Give a very brief answer. 7330.33. In the year 2001, what is the difference between the Emissions(kt) of Morocco and Emissions(kt) of Swaziland?
Offer a terse response. 1.23e+04. In the year 2001, what is the difference between the Emissions(kt) in New Zealand and Emissions(kt) in Swaziland?
Your response must be concise. 4946.78. In the year 2002, what is the difference between the Emissions(kt) of Israel and Emissions(kt) of Morocco?
Offer a very short reply. 1.62e+04. In the year 2002, what is the difference between the Emissions(kt) in Israel and Emissions(kt) in New Zealand?
Offer a terse response. 2.48e+04. In the year 2002, what is the difference between the Emissions(kt) of Israel and Emissions(kt) of Swaziland?
Keep it short and to the point. 2.88e+04. In the year 2002, what is the difference between the Emissions(kt) in Morocco and Emissions(kt) in New Zealand?
Offer a very short reply. 8646.79. In the year 2002, what is the difference between the Emissions(kt) in Morocco and Emissions(kt) in Swaziland?
Give a very brief answer. 1.26e+04. In the year 2002, what is the difference between the Emissions(kt) of New Zealand and Emissions(kt) of Swaziland?
Your response must be concise. 3982.36. In the year 2003, what is the difference between the Emissions(kt) in Israel and Emissions(kt) in Morocco?
Your response must be concise. 1.75e+04. In the year 2003, what is the difference between the Emissions(kt) of Israel and Emissions(kt) of New Zealand?
Offer a terse response. 2.28e+04. In the year 2003, what is the difference between the Emissions(kt) of Israel and Emissions(kt) of Swaziland?
Your answer should be very brief. 2.94e+04. In the year 2003, what is the difference between the Emissions(kt) in Morocco and Emissions(kt) in New Zealand?
Give a very brief answer. 5331.82. In the year 2003, what is the difference between the Emissions(kt) in Morocco and Emissions(kt) in Swaziland?
Keep it short and to the point. 1.18e+04. In the year 2003, what is the difference between the Emissions(kt) in New Zealand and Emissions(kt) in Swaziland?
Offer a very short reply. 6512.59. In the year 2004, what is the difference between the Emissions(kt) in Israel and Emissions(kt) in Morocco?
Give a very brief answer. 1.64e+04. In the year 2004, what is the difference between the Emissions(kt) of Israel and Emissions(kt) of New Zealand?
Offer a terse response. 2.18e+04. In the year 2004, what is the difference between the Emissions(kt) of Israel and Emissions(kt) of Swaziland?
Give a very brief answer. 2.97e+04. In the year 2004, what is the difference between the Emissions(kt) of Morocco and Emissions(kt) of New Zealand?
Offer a terse response. 5463.83. In the year 2004, what is the difference between the Emissions(kt) of Morocco and Emissions(kt) of Swaziland?
Ensure brevity in your answer.  1.33e+04. In the year 2004, what is the difference between the Emissions(kt) of New Zealand and Emissions(kt) of Swaziland?
Your response must be concise. 7843.71. In the year 2005, what is the difference between the Emissions(kt) of Israel and Emissions(kt) of Morocco?
Offer a terse response. 1.38e+04. In the year 2005, what is the difference between the Emissions(kt) of Israel and Emissions(kt) of New Zealand?
Your answer should be very brief. 1.93e+04. In the year 2005, what is the difference between the Emissions(kt) of Israel and Emissions(kt) of Swaziland?
Provide a succinct answer. 2.75e+04. In the year 2005, what is the difference between the Emissions(kt) of Morocco and Emissions(kt) of New Zealand?
Make the answer very short. 5577.51. In the year 2005, what is the difference between the Emissions(kt) in Morocco and Emissions(kt) in Swaziland?
Your answer should be very brief. 1.37e+04. In the year 2005, what is the difference between the Emissions(kt) in New Zealand and Emissions(kt) in Swaziland?
Keep it short and to the point. 8137.07. In the year 2006, what is the difference between the Emissions(kt) in Israel and Emissions(kt) in Morocco?
Give a very brief answer. 1.52e+04. In the year 2006, what is the difference between the Emissions(kt) in Israel and Emissions(kt) in New Zealand?
Provide a succinct answer. 2.23e+04. In the year 2006, what is the difference between the Emissions(kt) in Israel and Emissions(kt) in Swaziland?
Your answer should be very brief. 2.96e+04. In the year 2006, what is the difference between the Emissions(kt) in Morocco and Emissions(kt) in New Zealand?
Provide a short and direct response. 7069.98. In the year 2006, what is the difference between the Emissions(kt) of Morocco and Emissions(kt) of Swaziland?
Your answer should be compact. 1.43e+04. In the year 2006, what is the difference between the Emissions(kt) of New Zealand and Emissions(kt) of Swaziland?
Your answer should be very brief. 7256.99. What is the ratio of the Emissions(kt) in Israel in 1999 to that in 2000?
Your answer should be very brief. 0.87. What is the ratio of the Emissions(kt) in Morocco in 1999 to that in 2000?
Offer a terse response. 0.88. What is the ratio of the Emissions(kt) of New Zealand in 1999 to that in 2000?
Offer a very short reply. 1.1. What is the ratio of the Emissions(kt) in Swaziland in 1999 to that in 2000?
Provide a short and direct response. 1.09. What is the ratio of the Emissions(kt) of Israel in 1999 to that in 2001?
Provide a succinct answer. 0.8. What is the ratio of the Emissions(kt) in Morocco in 1999 to that in 2001?
Keep it short and to the point. 0.69. What is the ratio of the Emissions(kt) of New Zealand in 1999 to that in 2001?
Keep it short and to the point. 0.89. What is the ratio of the Emissions(kt) of Swaziland in 1999 to that in 2001?
Provide a short and direct response. 1.15. What is the ratio of the Emissions(kt) of Israel in 1999 to that in 2002?
Offer a terse response. 0.84. What is the ratio of the Emissions(kt) of Morocco in 1999 to that in 2002?
Give a very brief answer. 0.67. What is the ratio of the Emissions(kt) in New Zealand in 1999 to that in 2002?
Ensure brevity in your answer.  1.09. What is the ratio of the Emissions(kt) in Swaziland in 1999 to that in 2002?
Offer a terse response. 1.2. What is the ratio of the Emissions(kt) in Israel in 1999 to that in 2003?
Provide a short and direct response. 0.83. What is the ratio of the Emissions(kt) of Morocco in 1999 to that in 2003?
Give a very brief answer. 0.72. What is the ratio of the Emissions(kt) in New Zealand in 1999 to that in 2003?
Give a very brief answer. 0.7. What is the ratio of the Emissions(kt) in Swaziland in 1999 to that in 2003?
Give a very brief answer. 1.46. What is the ratio of the Emissions(kt) of Israel in 1999 to that in 2004?
Offer a very short reply. 0.82. What is the ratio of the Emissions(kt) in Morocco in 1999 to that in 2004?
Offer a very short reply. 0.65. What is the ratio of the Emissions(kt) of New Zealand in 1999 to that in 2004?
Make the answer very short. 0.59. What is the ratio of the Emissions(kt) in Swaziland in 1999 to that in 2004?
Keep it short and to the point. 1.49. What is the ratio of the Emissions(kt) in Israel in 1999 to that in 2005?
Your answer should be very brief. 0.88. What is the ratio of the Emissions(kt) in Morocco in 1999 to that in 2005?
Your answer should be compact. 0.63. What is the ratio of the Emissions(kt) of New Zealand in 1999 to that in 2005?
Your answer should be very brief. 0.57. What is the ratio of the Emissions(kt) in Swaziland in 1999 to that in 2005?
Offer a terse response. 1.53. What is the ratio of the Emissions(kt) in Israel in 1999 to that in 2006?
Keep it short and to the point. 0.82. What is the ratio of the Emissions(kt) of Morocco in 1999 to that in 2006?
Ensure brevity in your answer.  0.6. What is the ratio of the Emissions(kt) in New Zealand in 1999 to that in 2006?
Your answer should be very brief. 0.64. What is the ratio of the Emissions(kt) in Swaziland in 1999 to that in 2006?
Provide a short and direct response. 1.51. What is the ratio of the Emissions(kt) in Israel in 2000 to that in 2001?
Provide a short and direct response. 0.92. What is the ratio of the Emissions(kt) of Morocco in 2000 to that in 2001?
Make the answer very short. 0.79. What is the ratio of the Emissions(kt) in New Zealand in 2000 to that in 2001?
Your response must be concise. 0.81. What is the ratio of the Emissions(kt) of Swaziland in 2000 to that in 2001?
Your answer should be very brief. 1.06. What is the ratio of the Emissions(kt) of Israel in 2000 to that in 2002?
Offer a terse response. 0.96. What is the ratio of the Emissions(kt) in Morocco in 2000 to that in 2002?
Keep it short and to the point. 0.77. What is the ratio of the Emissions(kt) in New Zealand in 2000 to that in 2002?
Your answer should be compact. 0.99. What is the ratio of the Emissions(kt) in Swaziland in 2000 to that in 2002?
Offer a terse response. 1.1. What is the ratio of the Emissions(kt) in Israel in 2000 to that in 2003?
Make the answer very short. 0.95. What is the ratio of the Emissions(kt) of Morocco in 2000 to that in 2003?
Make the answer very short. 0.82. What is the ratio of the Emissions(kt) in New Zealand in 2000 to that in 2003?
Your answer should be compact. 0.64. What is the ratio of the Emissions(kt) in Swaziland in 2000 to that in 2003?
Your answer should be very brief. 1.34. What is the ratio of the Emissions(kt) in Israel in 2000 to that in 2004?
Your answer should be very brief. 0.94. What is the ratio of the Emissions(kt) in Morocco in 2000 to that in 2004?
Your answer should be very brief. 0.73. What is the ratio of the Emissions(kt) of New Zealand in 2000 to that in 2004?
Ensure brevity in your answer.  0.54. What is the ratio of the Emissions(kt) of Swaziland in 2000 to that in 2004?
Provide a short and direct response. 1.36. What is the ratio of the Emissions(kt) in Israel in 2000 to that in 2005?
Offer a very short reply. 1.01. What is the ratio of the Emissions(kt) of Morocco in 2000 to that in 2005?
Your answer should be very brief. 0.71. What is the ratio of the Emissions(kt) in New Zealand in 2000 to that in 2005?
Give a very brief answer. 0.52. What is the ratio of the Emissions(kt) in Swaziland in 2000 to that in 2005?
Keep it short and to the point. 1.4. What is the ratio of the Emissions(kt) in Israel in 2000 to that in 2006?
Your answer should be very brief. 0.94. What is the ratio of the Emissions(kt) of Morocco in 2000 to that in 2006?
Keep it short and to the point. 0.68. What is the ratio of the Emissions(kt) in New Zealand in 2000 to that in 2006?
Offer a very short reply. 0.58. What is the ratio of the Emissions(kt) in Swaziland in 2000 to that in 2006?
Make the answer very short. 1.39. What is the ratio of the Emissions(kt) of Israel in 2001 to that in 2002?
Offer a very short reply. 1.05. What is the ratio of the Emissions(kt) in Morocco in 2001 to that in 2002?
Keep it short and to the point. 0.97. What is the ratio of the Emissions(kt) of New Zealand in 2001 to that in 2002?
Provide a succinct answer. 1.22. What is the ratio of the Emissions(kt) of Swaziland in 2001 to that in 2002?
Your answer should be very brief. 1.04. What is the ratio of the Emissions(kt) of Israel in 2001 to that in 2003?
Offer a terse response. 1.03. What is the ratio of the Emissions(kt) of Morocco in 2001 to that in 2003?
Make the answer very short. 1.04. What is the ratio of the Emissions(kt) in New Zealand in 2001 to that in 2003?
Keep it short and to the point. 0.79. What is the ratio of the Emissions(kt) of Swaziland in 2001 to that in 2003?
Your answer should be very brief. 1.27. What is the ratio of the Emissions(kt) in Israel in 2001 to that in 2004?
Your answer should be very brief. 1.02. What is the ratio of the Emissions(kt) in Morocco in 2001 to that in 2004?
Give a very brief answer. 0.93. What is the ratio of the Emissions(kt) of New Zealand in 2001 to that in 2004?
Give a very brief answer. 0.66. What is the ratio of the Emissions(kt) of Swaziland in 2001 to that in 2004?
Your answer should be compact. 1.29. What is the ratio of the Emissions(kt) of Israel in 2001 to that in 2005?
Your answer should be very brief. 1.1. What is the ratio of the Emissions(kt) of Morocco in 2001 to that in 2005?
Your answer should be compact. 0.91. What is the ratio of the Emissions(kt) of New Zealand in 2001 to that in 2005?
Offer a very short reply. 0.64. What is the ratio of the Emissions(kt) of Swaziland in 2001 to that in 2005?
Ensure brevity in your answer.  1.33. What is the ratio of the Emissions(kt) in Morocco in 2001 to that in 2006?
Offer a terse response. 0.87. What is the ratio of the Emissions(kt) in New Zealand in 2001 to that in 2006?
Offer a terse response. 0.71. What is the ratio of the Emissions(kt) of Swaziland in 2001 to that in 2006?
Provide a succinct answer. 1.31. What is the ratio of the Emissions(kt) in Israel in 2002 to that in 2003?
Provide a succinct answer. 0.98. What is the ratio of the Emissions(kt) of Morocco in 2002 to that in 2003?
Your response must be concise. 1.07. What is the ratio of the Emissions(kt) in New Zealand in 2002 to that in 2003?
Provide a short and direct response. 0.65. What is the ratio of the Emissions(kt) of Swaziland in 2002 to that in 2003?
Provide a succinct answer. 1.22. What is the ratio of the Emissions(kt) in Israel in 2002 to that in 2004?
Keep it short and to the point. 0.97. What is the ratio of the Emissions(kt) of Morocco in 2002 to that in 2004?
Your answer should be very brief. 0.96. What is the ratio of the Emissions(kt) in New Zealand in 2002 to that in 2004?
Your response must be concise. 0.54. What is the ratio of the Emissions(kt) in Swaziland in 2002 to that in 2004?
Ensure brevity in your answer.  1.24. What is the ratio of the Emissions(kt) in Israel in 2002 to that in 2005?
Your answer should be compact. 1.05. What is the ratio of the Emissions(kt) of Morocco in 2002 to that in 2005?
Keep it short and to the point. 0.93. What is the ratio of the Emissions(kt) of New Zealand in 2002 to that in 2005?
Provide a succinct answer. 0.52. What is the ratio of the Emissions(kt) of Swaziland in 2002 to that in 2005?
Give a very brief answer. 1.28. What is the ratio of the Emissions(kt) of Israel in 2002 to that in 2006?
Offer a very short reply. 0.98. What is the ratio of the Emissions(kt) of Morocco in 2002 to that in 2006?
Keep it short and to the point. 0.89. What is the ratio of the Emissions(kt) in New Zealand in 2002 to that in 2006?
Provide a short and direct response. 0.58. What is the ratio of the Emissions(kt) of Swaziland in 2002 to that in 2006?
Your answer should be very brief. 1.27. What is the ratio of the Emissions(kt) in Israel in 2003 to that in 2004?
Ensure brevity in your answer.  0.99. What is the ratio of the Emissions(kt) of Morocco in 2003 to that in 2004?
Offer a terse response. 0.89. What is the ratio of the Emissions(kt) in New Zealand in 2003 to that in 2004?
Keep it short and to the point. 0.84. What is the ratio of the Emissions(kt) in Swaziland in 2003 to that in 2004?
Your answer should be compact. 1.02. What is the ratio of the Emissions(kt) in Israel in 2003 to that in 2005?
Ensure brevity in your answer.  1.07. What is the ratio of the Emissions(kt) of Morocco in 2003 to that in 2005?
Your response must be concise. 0.87. What is the ratio of the Emissions(kt) in New Zealand in 2003 to that in 2005?
Offer a very short reply. 0.81. What is the ratio of the Emissions(kt) of Swaziland in 2003 to that in 2005?
Your response must be concise. 1.05. What is the ratio of the Emissions(kt) in Israel in 2003 to that in 2006?
Give a very brief answer. 0.99. What is the ratio of the Emissions(kt) in Morocco in 2003 to that in 2006?
Provide a succinct answer. 0.83. What is the ratio of the Emissions(kt) in New Zealand in 2003 to that in 2006?
Your response must be concise. 0.9. What is the ratio of the Emissions(kt) of Swaziland in 2003 to that in 2006?
Your response must be concise. 1.04. What is the ratio of the Emissions(kt) in Israel in 2004 to that in 2005?
Keep it short and to the point. 1.08. What is the ratio of the Emissions(kt) of Morocco in 2004 to that in 2005?
Keep it short and to the point. 0.97. What is the ratio of the Emissions(kt) in New Zealand in 2004 to that in 2005?
Offer a very short reply. 0.97. What is the ratio of the Emissions(kt) of Swaziland in 2004 to that in 2005?
Offer a very short reply. 1.03. What is the ratio of the Emissions(kt) in Morocco in 2004 to that in 2006?
Make the answer very short. 0.93. What is the ratio of the Emissions(kt) of New Zealand in 2004 to that in 2006?
Offer a terse response. 1.08. What is the ratio of the Emissions(kt) in Swaziland in 2004 to that in 2006?
Your response must be concise. 1.02. What is the ratio of the Emissions(kt) of Israel in 2005 to that in 2006?
Ensure brevity in your answer.  0.93. What is the ratio of the Emissions(kt) of Morocco in 2005 to that in 2006?
Keep it short and to the point. 0.96. What is the ratio of the Emissions(kt) in New Zealand in 2005 to that in 2006?
Your response must be concise. 1.11. What is the difference between the highest and the second highest Emissions(kt) in Israel?
Provide a succinct answer. 539.05. What is the difference between the highest and the second highest Emissions(kt) in Morocco?
Your response must be concise. 616.06. What is the difference between the highest and the second highest Emissions(kt) in New Zealand?
Give a very brief answer. 282.36. What is the difference between the highest and the second highest Emissions(kt) of Swaziland?
Ensure brevity in your answer.  47.67. What is the difference between the highest and the lowest Emissions(kt) of Israel?
Give a very brief answer. 5988.21. What is the difference between the highest and the lowest Emissions(kt) of Morocco?
Your answer should be very brief. 5870.87. What is the difference between the highest and the lowest Emissions(kt) in New Zealand?
Your answer should be very brief. 4085.04. What is the difference between the highest and the lowest Emissions(kt) in Swaziland?
Your answer should be very brief. 201.69. 